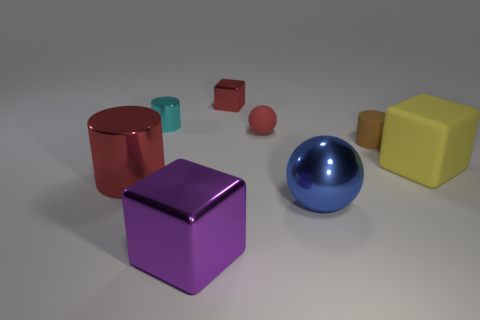There is a red block that is the same material as the cyan object; what is its size?
Offer a very short reply. Small. What number of tiny cylinders have the same color as the large cylinder?
Keep it short and to the point. 0. There is a shiny cylinder that is behind the rubber block; is it the same size as the brown matte cylinder?
Give a very brief answer. Yes. What color is the thing that is both in front of the cyan metal thing and behind the tiny brown cylinder?
Keep it short and to the point. Red. What number of things are either small red shiny things or big cubes that are right of the large purple thing?
Keep it short and to the point. 2. What is the material of the big block on the left side of the large metallic thing right of the metal block behind the tiny metal cylinder?
Your answer should be very brief. Metal. Does the block behind the tiny cyan cylinder have the same color as the big cylinder?
Your answer should be compact. Yes. What number of cyan objects are tiny metal cylinders or spheres?
Ensure brevity in your answer.  1. What number of other things are the same shape as the large blue shiny thing?
Keep it short and to the point. 1. Is the material of the big red object the same as the tiny brown object?
Ensure brevity in your answer.  No. 